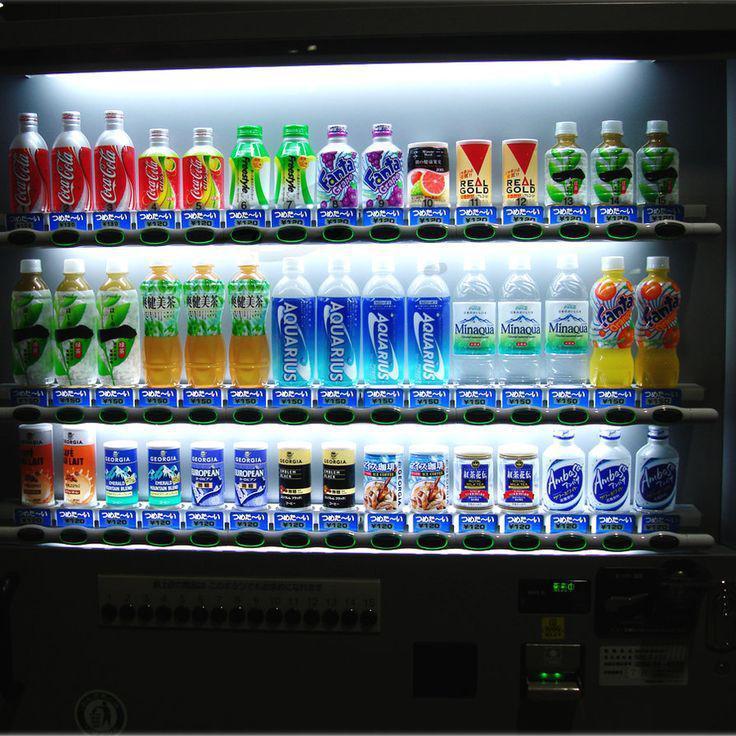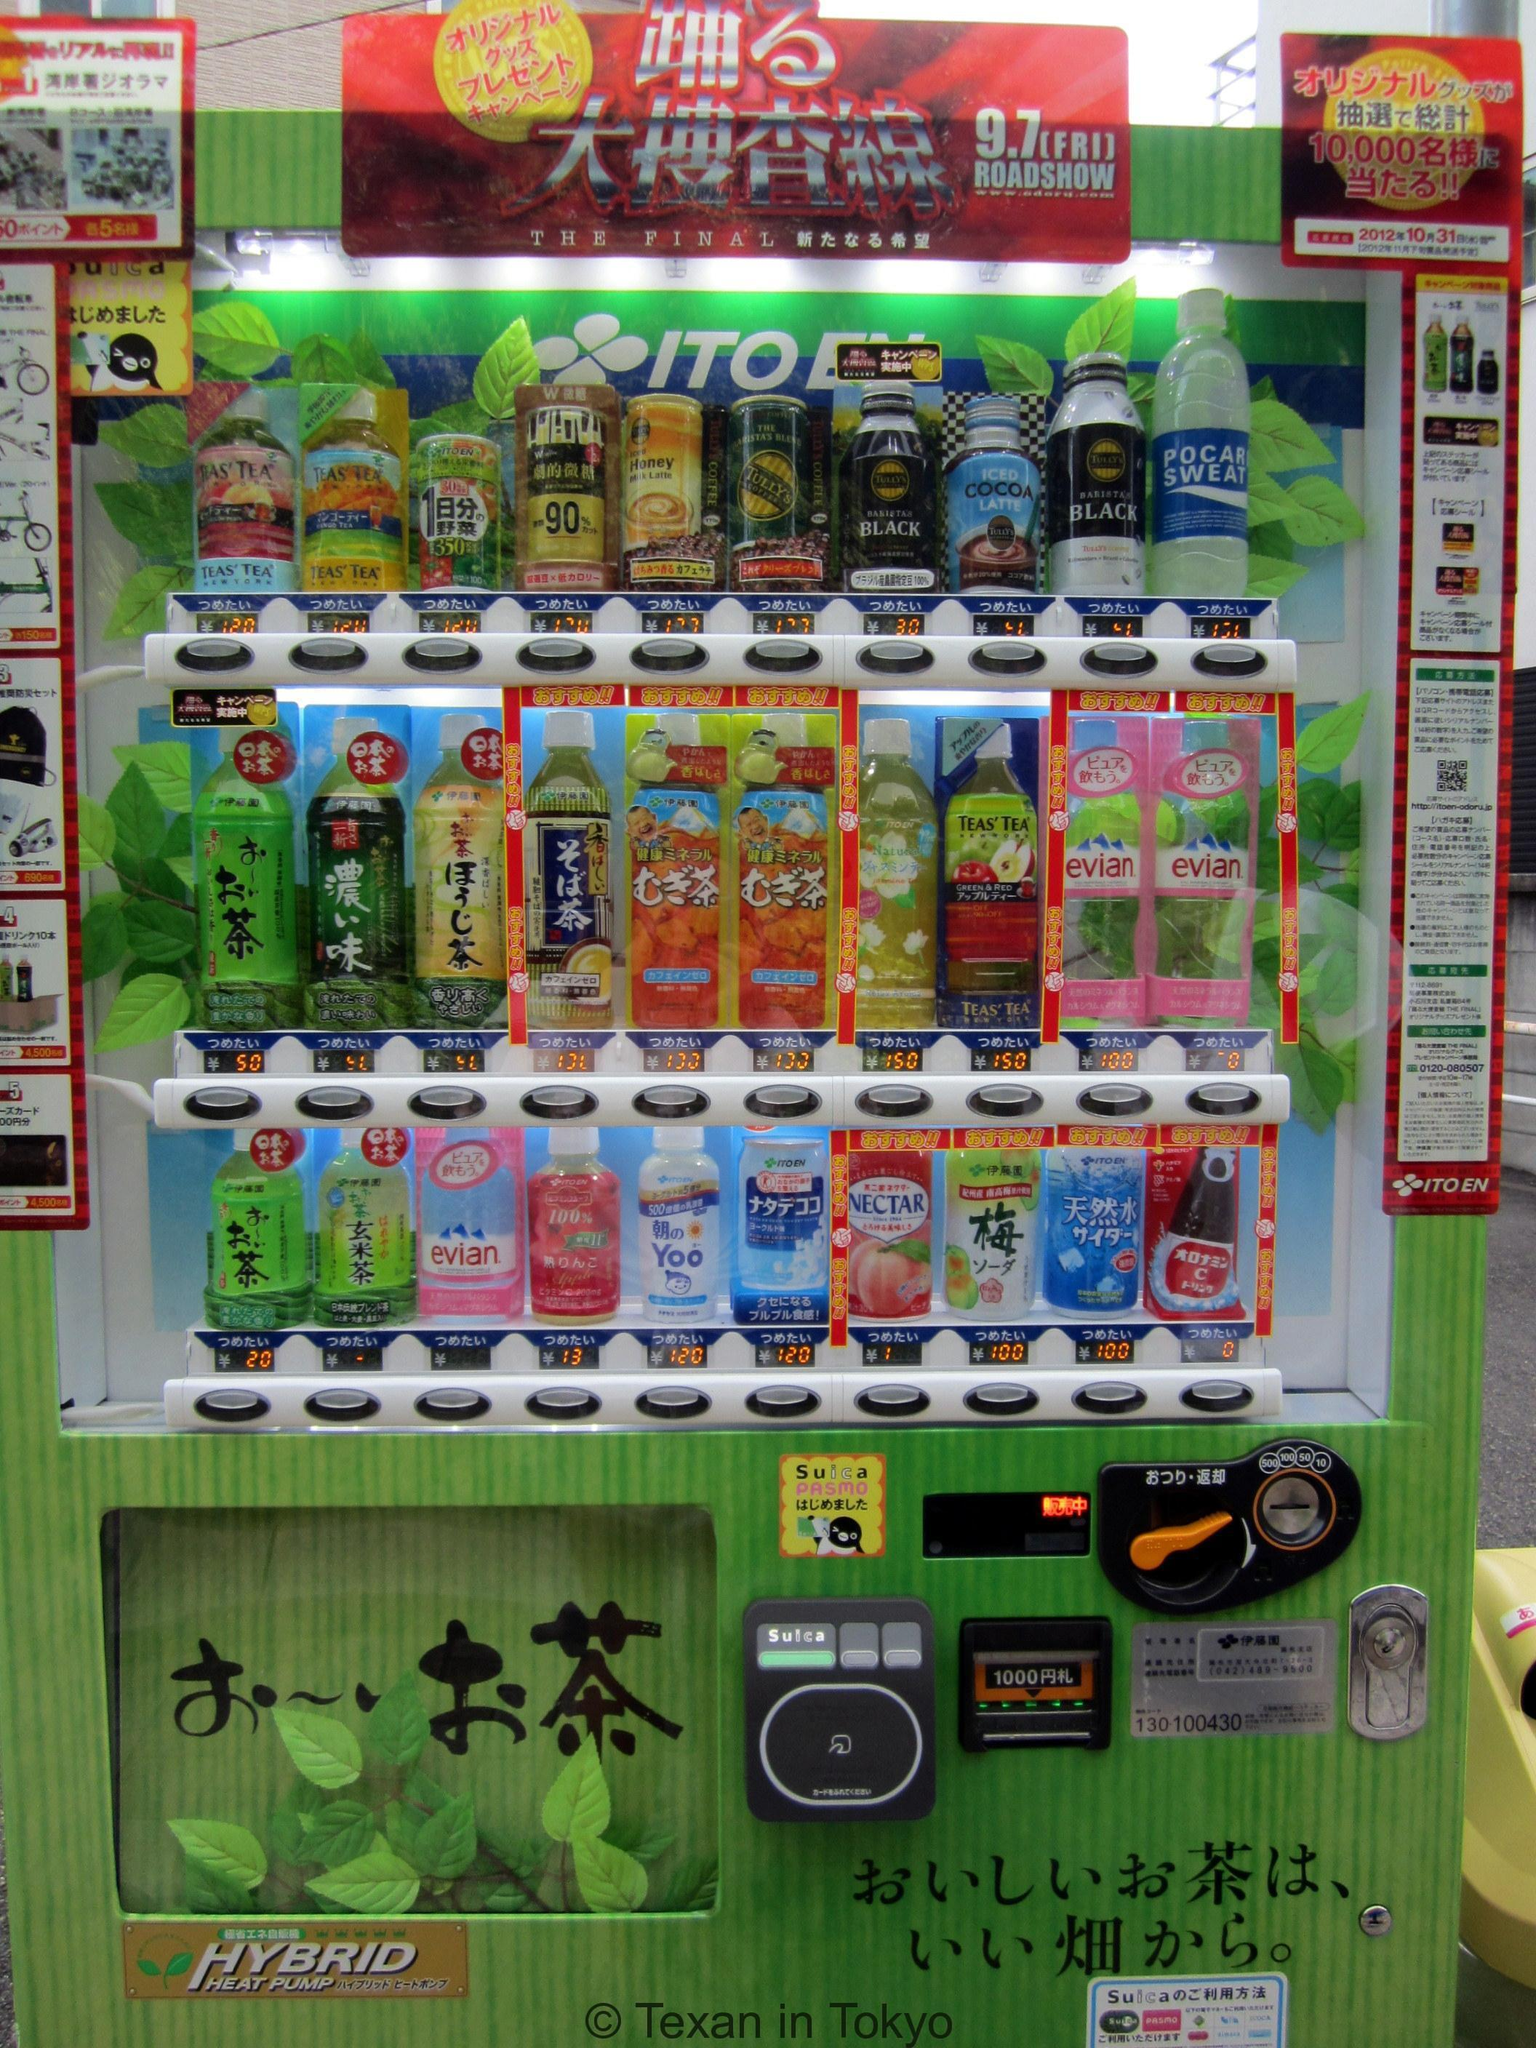The first image is the image on the left, the second image is the image on the right. Evaluate the accuracy of this statement regarding the images: "An image is focused on one vending machine, which features on its front large Asian characters on a field of red, yellow and blue stripes.". Is it true? Answer yes or no. No. The first image is the image on the left, the second image is the image on the right. Considering the images on both sides, is "The left image contains a single vending machine." valid? Answer yes or no. Yes. 